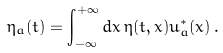<formula> <loc_0><loc_0><loc_500><loc_500>\eta _ { a } ( t ) = \int _ { - \infty } ^ { + \infty } d x \, \eta ( t , x ) u _ { a } ^ { * } ( x ) \, .</formula> 